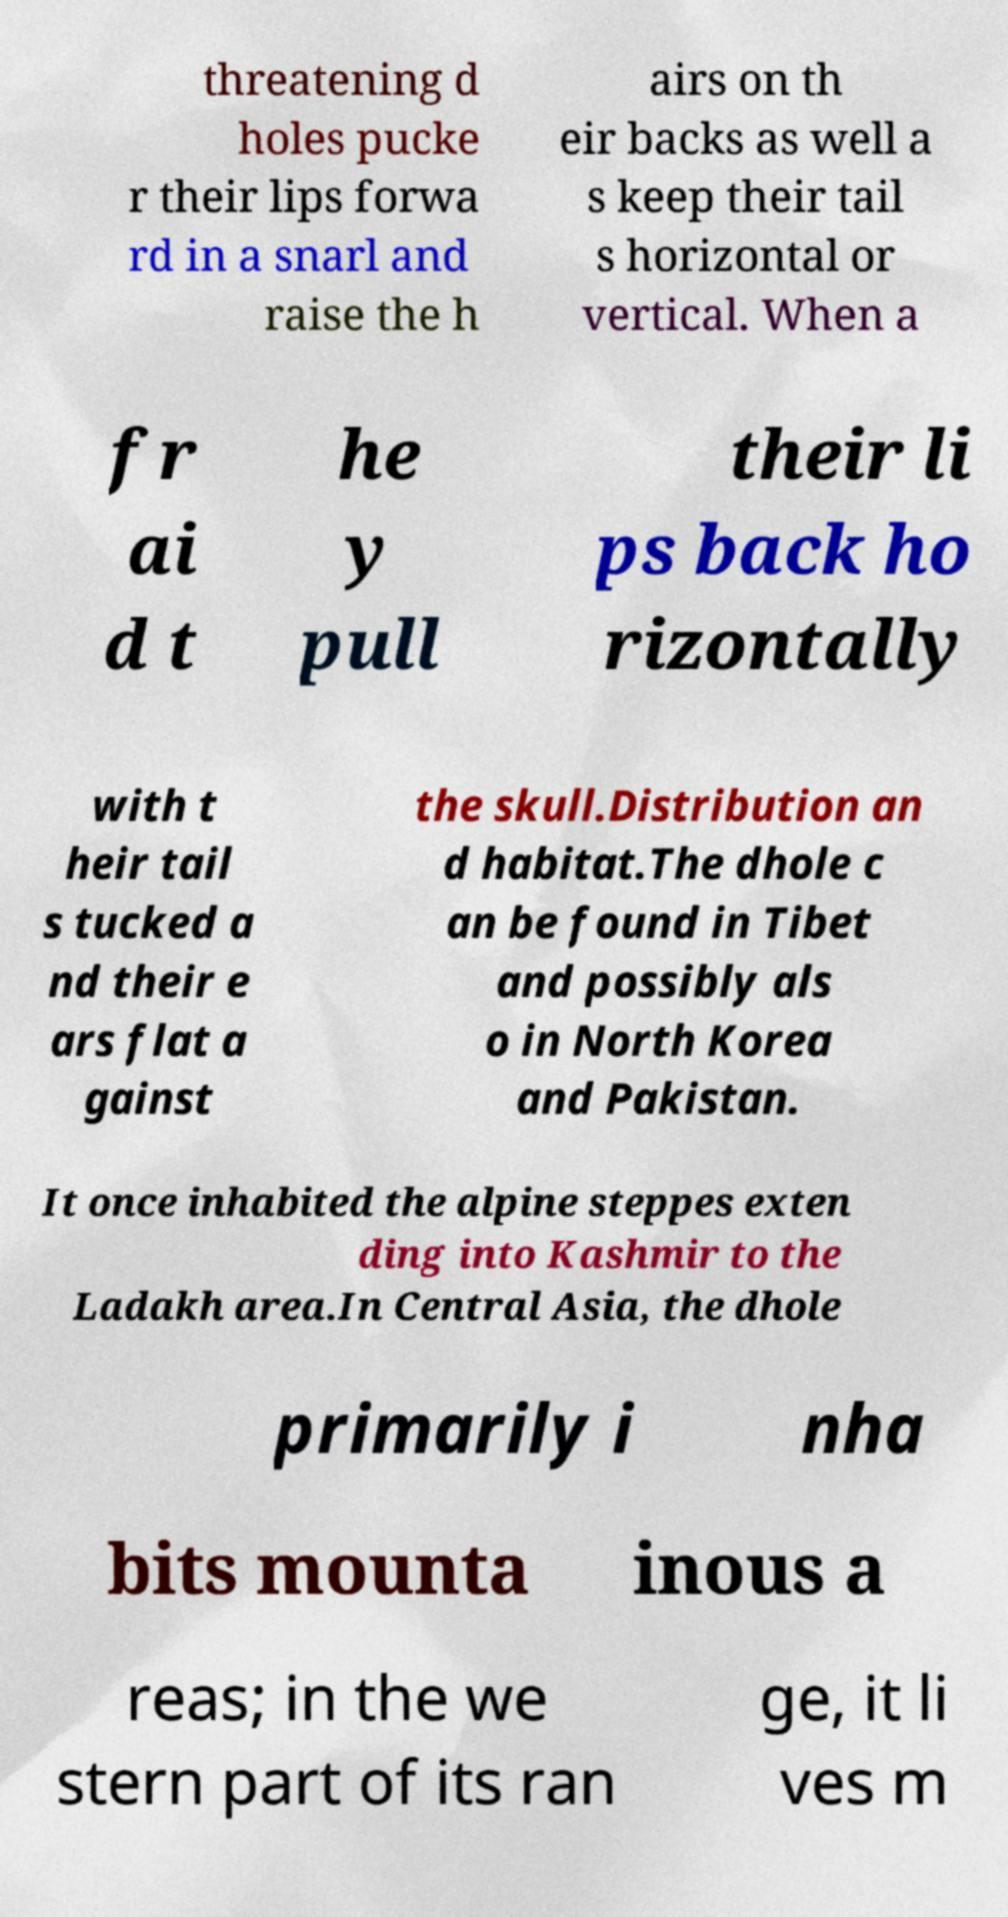What messages or text are displayed in this image? I need them in a readable, typed format. threatening d holes pucke r their lips forwa rd in a snarl and raise the h airs on th eir backs as well a s keep their tail s horizontal or vertical. When a fr ai d t he y pull their li ps back ho rizontally with t heir tail s tucked a nd their e ars flat a gainst the skull.Distribution an d habitat.The dhole c an be found in Tibet and possibly als o in North Korea and Pakistan. It once inhabited the alpine steppes exten ding into Kashmir to the Ladakh area.In Central Asia, the dhole primarily i nha bits mounta inous a reas; in the we stern part of its ran ge, it li ves m 